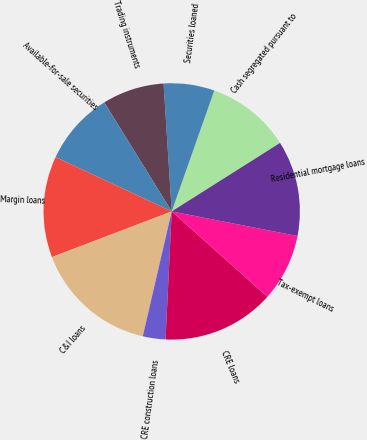Convert chart to OTSL. <chart><loc_0><loc_0><loc_500><loc_500><pie_chart><fcel>Cash segregated pursuant to<fcel>Securities loaned<fcel>Trading instruments<fcel>Available-for-sale securities<fcel>Margin loans<fcel>C&I loans<fcel>CRE construction loans<fcel>CRE loans<fcel>Tax-exempt loans<fcel>Residential mortgage loans<nl><fcel>10.64%<fcel>6.4%<fcel>7.81%<fcel>9.22%<fcel>12.76%<fcel>15.58%<fcel>2.86%<fcel>14.17%<fcel>8.52%<fcel>12.05%<nl></chart> 